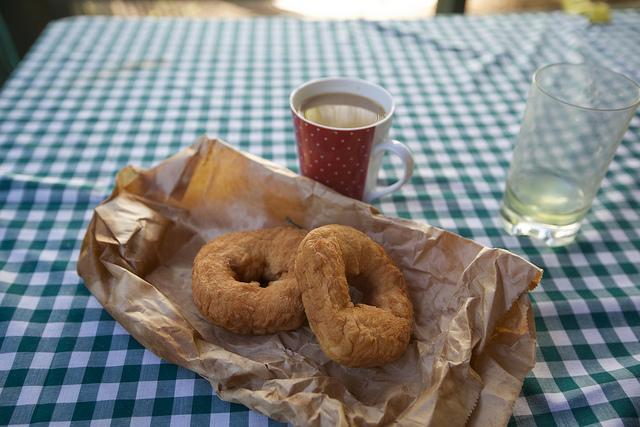What type of donuts are these?

Choices:
A) chocolate
B) glazed
C) plain cake
D) powdered sugar plain cake 